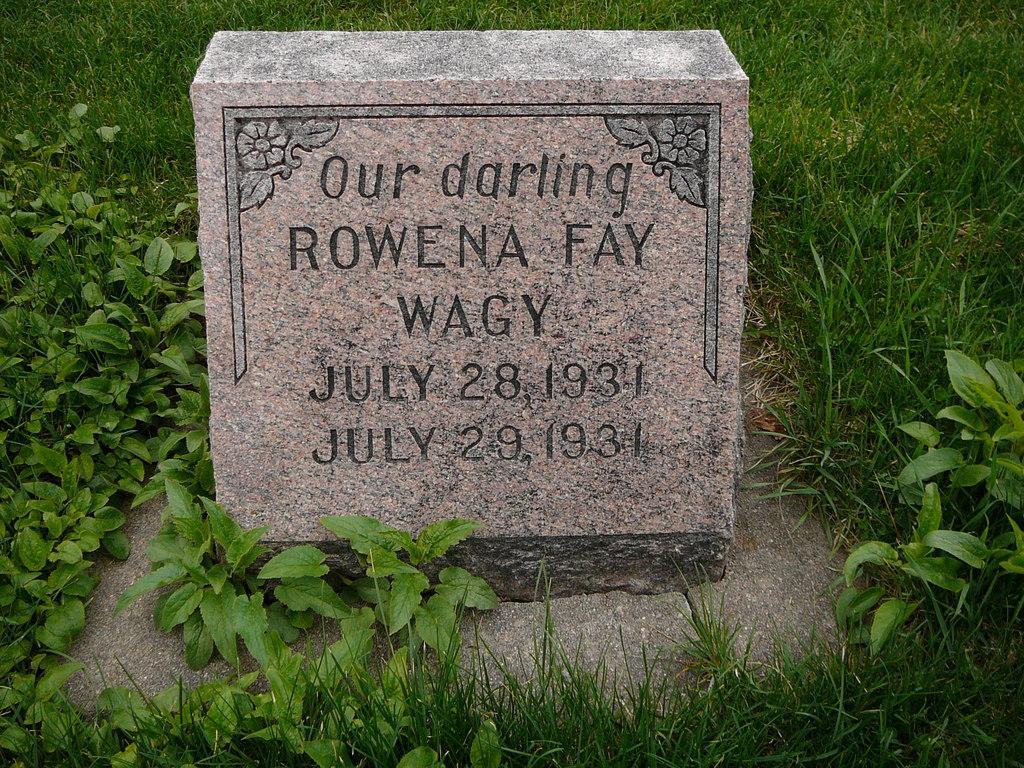Can you describe this image briefly? In this image we can see a gravestone, around the gravestone we can see some plants and grass. 